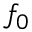<formula> <loc_0><loc_0><loc_500><loc_500>f _ { 0 }</formula> 